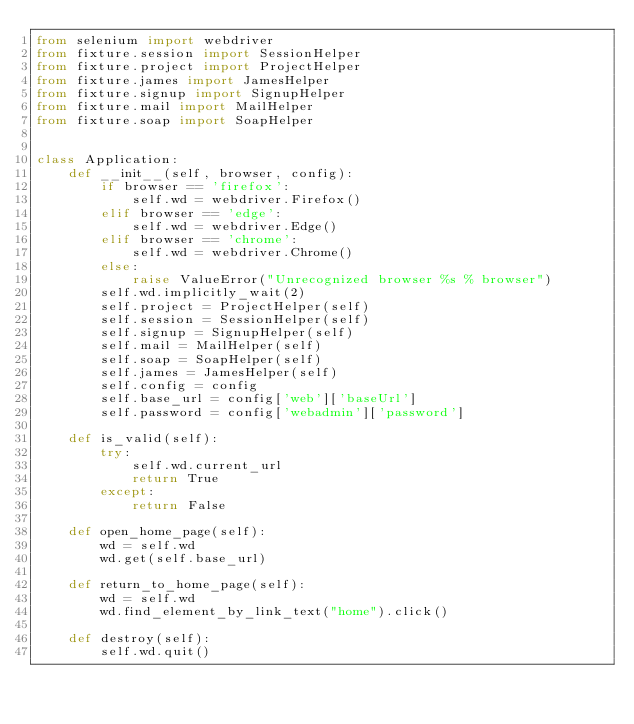<code> <loc_0><loc_0><loc_500><loc_500><_Python_>from selenium import webdriver
from fixture.session import SessionHelper
from fixture.project import ProjectHelper
from fixture.james import JamesHelper
from fixture.signup import SignupHelper
from fixture.mail import MailHelper
from fixture.soap import SoapHelper


class Application:
    def __init__(self, browser, config):
        if browser == 'firefox':
            self.wd = webdriver.Firefox()
        elif browser == 'edge':
            self.wd = webdriver.Edge()
        elif browser == 'chrome':
            self.wd = webdriver.Chrome()
        else:
            raise ValueError("Unrecognized browser %s % browser")
        self.wd.implicitly_wait(2)
        self.project = ProjectHelper(self)
        self.session = SessionHelper(self)
        self.signup = SignupHelper(self)
        self.mail = MailHelper(self)
        self.soap = SoapHelper(self)
        self.james = JamesHelper(self)
        self.config = config
        self.base_url = config['web']['baseUrl']
        self.password = config['webadmin']['password']

    def is_valid(self):
        try:
            self.wd.current_url
            return True
        except:
            return False

    def open_home_page(self):
        wd = self.wd
        wd.get(self.base_url)

    def return_to_home_page(self):
        wd = self.wd
        wd.find_element_by_link_text("home").click()

    def destroy(self):
        self.wd.quit()

</code> 